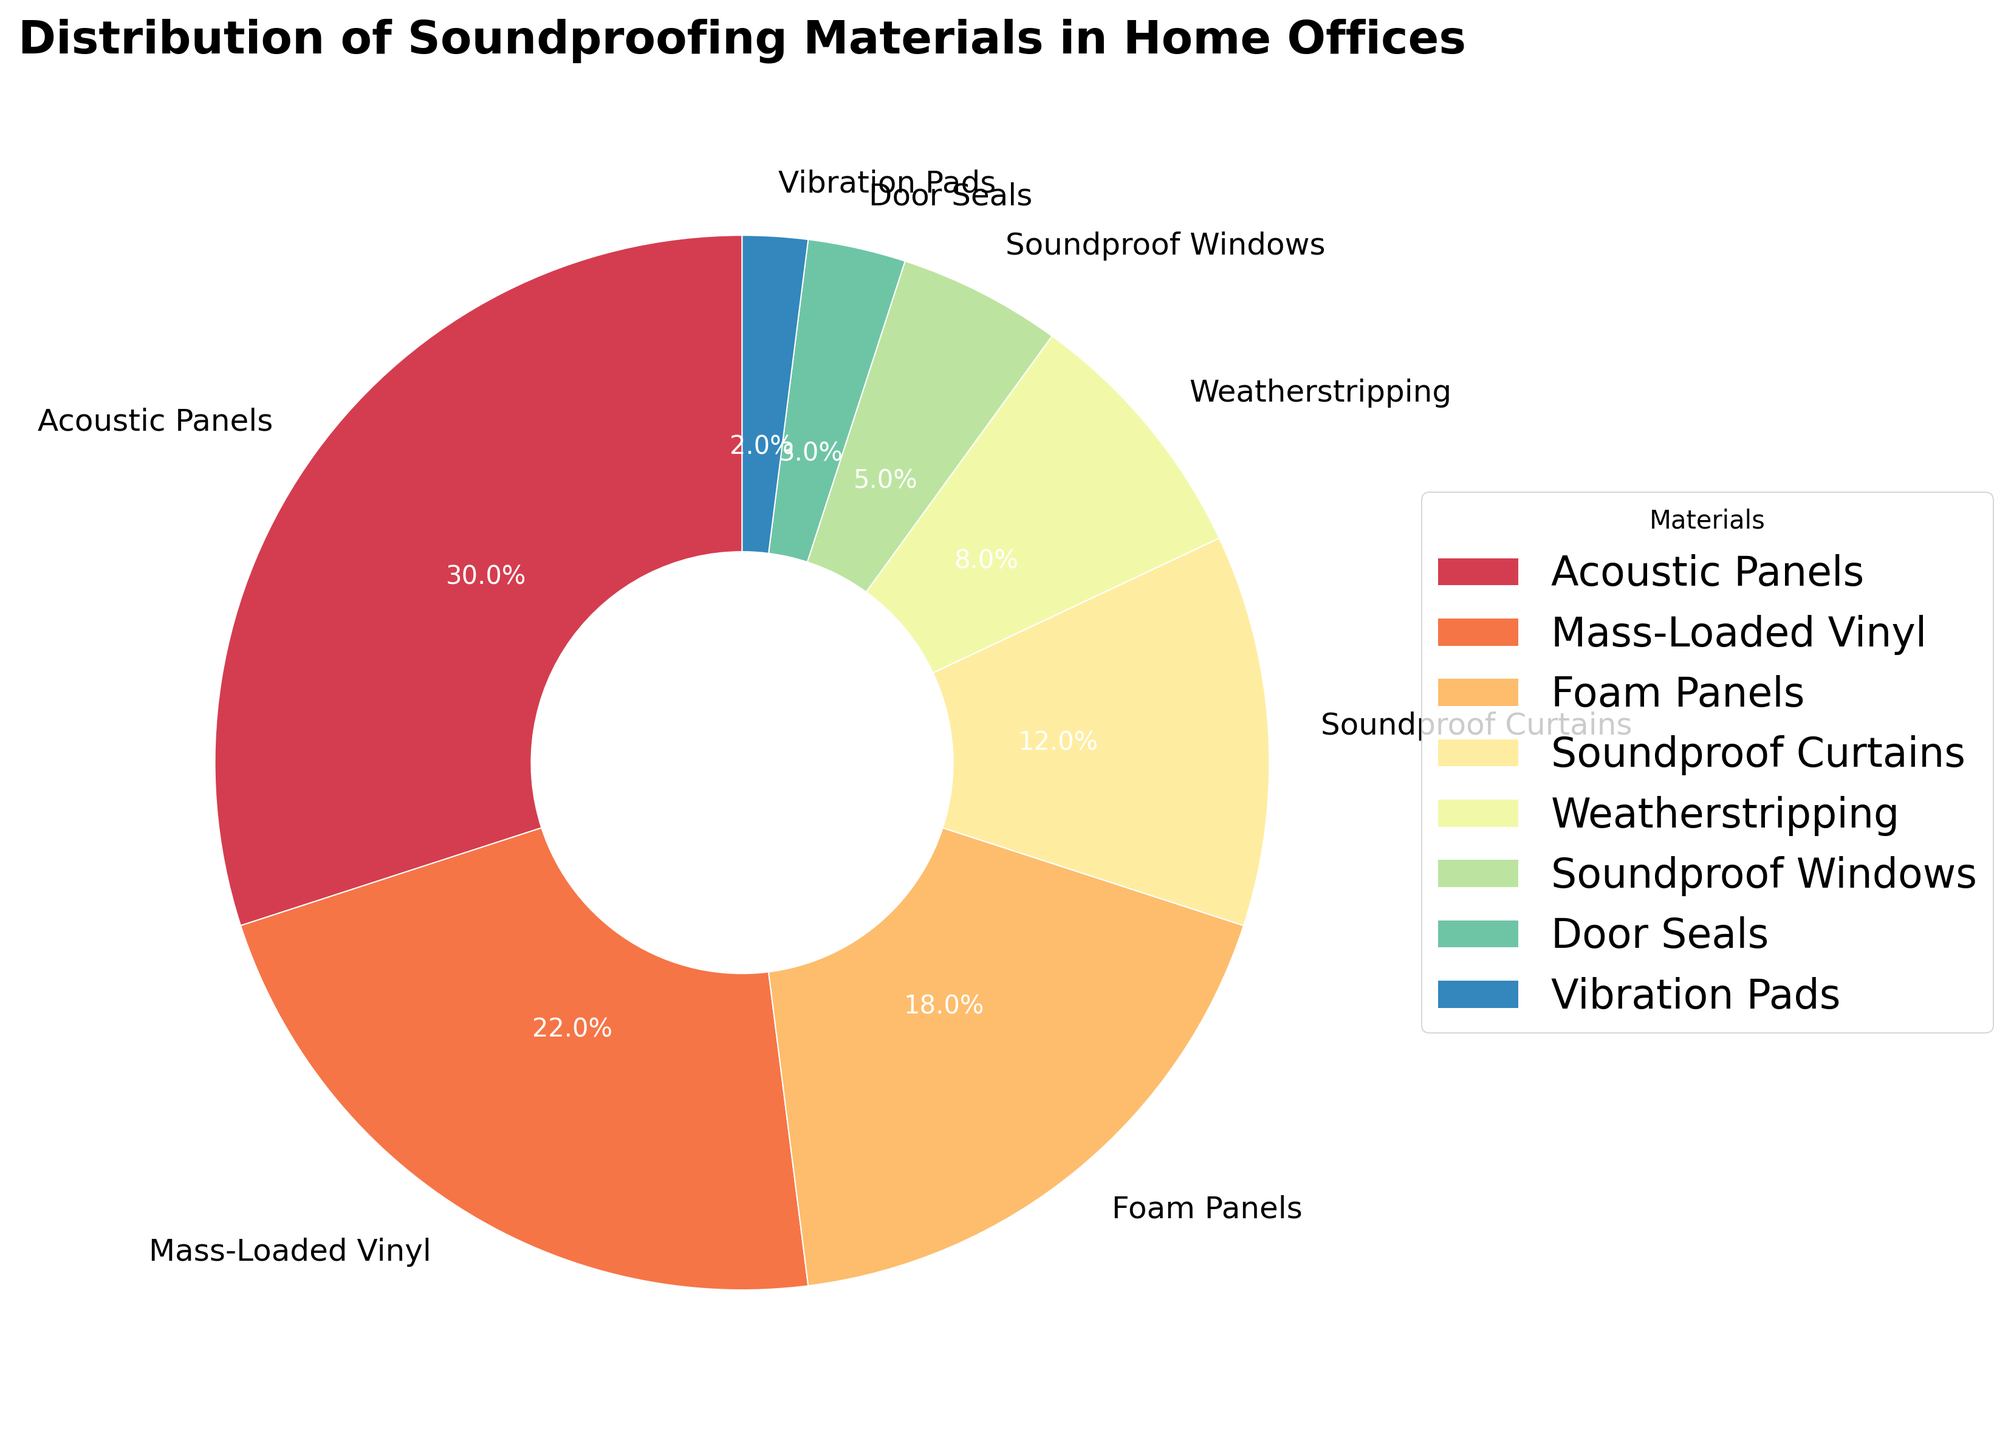What's the combined percentage of Acoustic Panels and Mass-Loaded Vinyl? We need to add the percentages of Acoustic Panels (30%) and Mass-Loaded Vinyl (22%). So, 30% + 22% = 52%.
Answer: 52% Which material has the lowest percentage, and what is it? To find the material with the lowest percentage, look for the smallest slice in the pie chart. The smallest slice is for Vibration Pads at 2%.
Answer: Vibration Pads, 2% How much more popular are Acoustic Panels compared to Foam Panels? To find the difference, subtract the Foam Panels percentage (18%) from the Acoustic Panels percentage (30%). So, 30% - 18% = 12%.
Answer: 12% Is the percentage of Soundproof Curtains more than weatherstripping, and if so, by how much? To check, subtract the percentage of weatherstripping (8%) from Soundproof Curtains (12%). So, 12% - 8% = 4%.
Answer: Yes, by 4% If you combined the percentages of Soundproof Windows and Door Seals, would it be more or less than Weatherstripping? Add the percentages of Soundproof Windows (5%) and Door Seals (3%), then compare with Weatherstripping (8%). So, 5% + 3% = 8%, which is equal to Weatherstripping.
Answer: Equal Which material is represented by the largest slice, and what is its percentage? The largest slice in the pie chart corresponds to Acoustic Panels at 30%.
Answer: Acoustic Panels, 30% Arrange the materials in order of their percentages from highest to lowest. Ordering the materials by their percentages: Acoustic Panels (30%), Mass-Loaded Vinyl (22%), Foam Panels (18%), Soundproof Curtains (12%), Weatherstripping (8%), Soundproof Windows (5%), Door Seals (3%), Vibration Pads (2%).
Answer: Acoustic Panels, Mass-Loaded Vinyl, Foam Panels, Soundproof Curtains, Weatherstripping, Soundproof Windows, Door Seals, Vibration Pads What's the total percentage of materials that contribute less than 10% each? Sum the percentages of materials that are less than 10%: Weatherstripping (8%), Soundproof Windows (5%), Door Seals (3%), Vibration Pads (2%). So, 8% + 5% + 3% + 2% = 18%.
Answer: 18% If you were to recommend a combination of three materials that cover at least 50% of the distribution, which ones would you choose? To find a combination that covers at least 50%, we can choose Acoustic Panels (30%), Mass-Loaded Vinyl (22%), totaling 52%. Just two materials suffice. Alternatively, adding Foam Panels (18%) is also enough (30% + 22% + 18% = 70%).
Answer: Acoustic Panels and Mass-Loaded Vinyl 